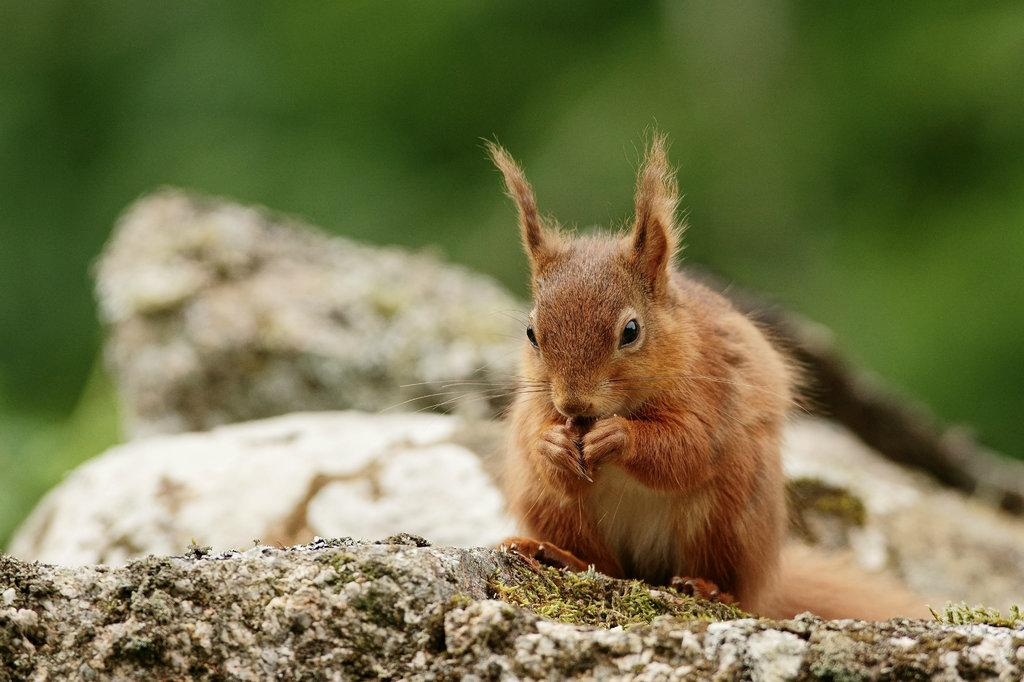What type of animal is in the image? There is a squirrel in the image. Can you describe the background of the image? The background of the image is blurry. What color is the chalk used by the squirrel in the image? There is no chalk present in the image, and the squirrel is not shown using any chalk. 